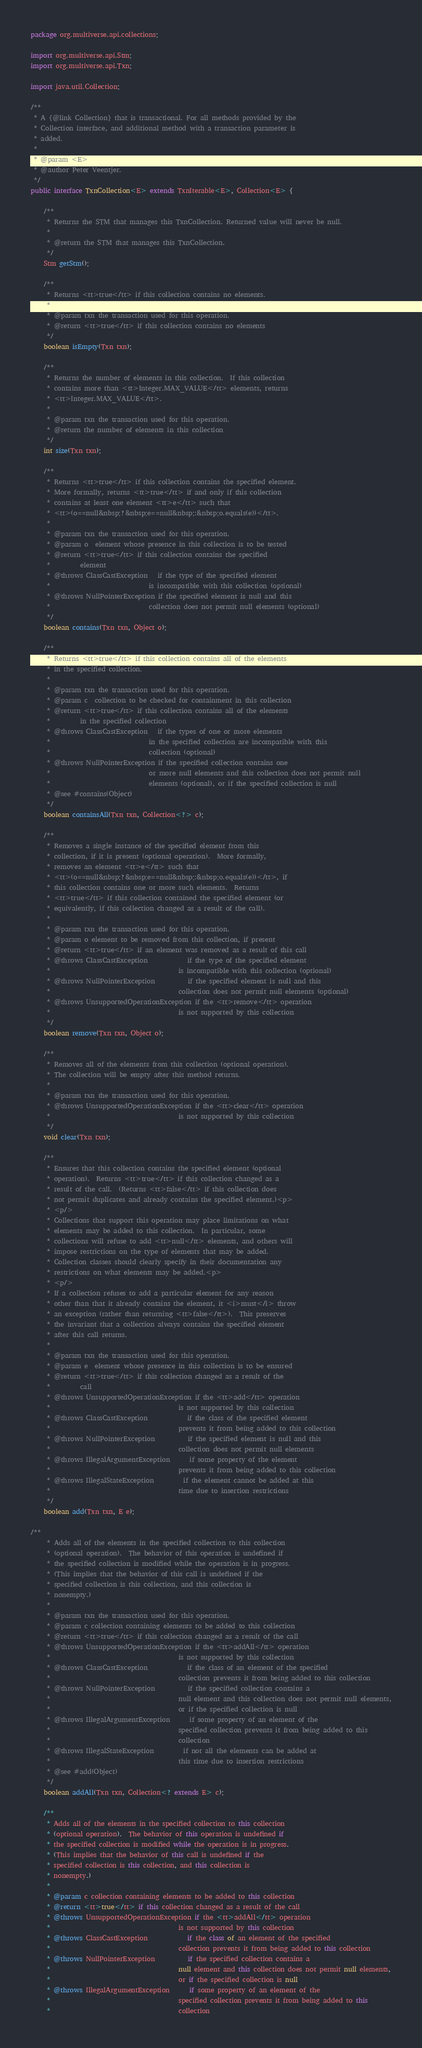<code> <loc_0><loc_0><loc_500><loc_500><_Java_>package org.multiverse.api.collections;

import org.multiverse.api.Stm;
import org.multiverse.api.Txn;

import java.util.Collection;

/**
 * A {@link Collection} that is transactional. For all methods provided by the
 * Collection interface, and additional method with a transaction parameter is
 * added.
 *
 * @param <E>
 * @author Peter Veentjer.
 */
public interface TxnCollection<E> extends TxnIterable<E>, Collection<E> {

    /**
     * Returns the STM that manages this TxnCollection. Returned value will never be null.
     *
     * @return the STM that manages this TxnCollection.
     */
    Stm getStm();

    /**
     * Returns <tt>true</tt> if this collection contains no elements.
     *
     * @param txn the transaction used for this operation.
     * @return <tt>true</tt> if this collection contains no elements
     */
    boolean isEmpty(Txn txn);

    /**
     * Returns the number of elements in this collection.  If this collection
     * contains more than <tt>Integer.MAX_VALUE</tt> elements, returns
     * <tt>Integer.MAX_VALUE</tt>.
     *
     * @param txn the transaction used for this operation.
     * @return the number of elements in this collection
     */
    int size(Txn txn);

    /**
     * Returns <tt>true</tt> if this collection contains the specified element.
     * More formally, returns <tt>true</tt> if and only if this collection
     * contains at least one element <tt>e</tt> such that
     * <tt>(o==null&nbsp;?&nbsp;e==null&nbsp;:&nbsp;o.equals(e))</tt>.
     *
     * @param txn the transaction used for this operation.
     * @param o  element whose presence in this collection is to be tested
     * @return <tt>true</tt> if this collection contains the specified
     *         element
     * @throws ClassCastException   if the type of the specified element
     *                              is incompatible with this collection (optional)
     * @throws NullPointerException if the specified element is null and this
     *                              collection does not permit null elements (optional)
     */
    boolean contains(Txn txn, Object o);

    /**
     * Returns <tt>true</tt> if this collection contains all of the elements
     * in the specified collection.
     *
     * @param txn the transaction used for this operation.
     * @param c  collection to be checked for containment in this collection
     * @return <tt>true</tt> if this collection contains all of the elements
     *         in the specified collection
     * @throws ClassCastException   if the types of one or more elements
     *                              in the specified collection are incompatible with this
     *                              collection (optional)
     * @throws NullPointerException if the specified collection contains one
     *                              or more null elements and this collection does not permit null
     *                              elements (optional), or if the specified collection is null
     * @see #contains(Object)
     */
    boolean containsAll(Txn txn, Collection<?> c);

    /**
     * Removes a single instance of the specified element from this
     * collection, if it is present (optional operation).  More formally,
     * removes an element <tt>e</tt> such that
     * <tt>(o==null&nbsp;?&nbsp;e==null&nbsp;:&nbsp;o.equals(e))</tt>, if
     * this collection contains one or more such elements.  Returns
     * <tt>true</tt> if this collection contained the specified element (or
     * equivalently, if this collection changed as a result of the call).
     *
     * @param txn the transaction used for this operation.
     * @param o element to be removed from this collection, if present
     * @return <tt>true</tt> if an element was removed as a result of this call
     * @throws ClassCastException            if the type of the specified element
     *                                       is incompatible with this collection (optional)
     * @throws NullPointerException          if the specified element is null and this
     *                                       collection does not permit null elements (optional)
     * @throws UnsupportedOperationException if the <tt>remove</tt> operation
     *                                       is not supported by this collection
     */
    boolean remove(Txn txn, Object o);

    /**
     * Removes all of the elements from this collection (optional operation).
     * The collection will be empty after this method returns.
     *
     * @param txn the transaction used for this operation.
     * @throws UnsupportedOperationException if the <tt>clear</tt> operation
     *                                       is not supported by this collection
     */
    void clear(Txn txn);

    /**
     * Ensures that this collection contains the specified element (optional
     * operation).  Returns <tt>true</tt> if this collection changed as a
     * result of the call.  (Returns <tt>false</tt> if this collection does
     * not permit duplicates and already contains the specified element.)<p>
     * <p/>
     * Collections that support this operation may place limitations on what
     * elements may be added to this collection.  In particular, some
     * collections will refuse to add <tt>null</tt> elements, and others will
     * impose restrictions on the type of elements that may be added.
     * Collection classes should clearly specify in their documentation any
     * restrictions on what elements may be added.<p>
     * <p/>
     * If a collection refuses to add a particular element for any reason
     * other than that it already contains the element, it <i>must</i> throw
     * an exception (rather than returning <tt>false</tt>).  This preserves
     * the invariant that a collection always contains the specified element
     * after this call returns.
     *
     * @param txn the transaction used for this operation.
     * @param e  element whose presence in this collection is to be ensured
     * @return <tt>true</tt> if this collection changed as a result of the
     *         call
     * @throws UnsupportedOperationException if the <tt>add</tt> operation
     *                                       is not supported by this collection
     * @throws ClassCastException            if the class of the specified element
     *                                       prevents it from being added to this collection
     * @throws NullPointerException          if the specified element is null and this
     *                                       collection does not permit null elements
     * @throws IllegalArgumentException      if some property of the element
     *                                       prevents it from being added to this collection
     * @throws IllegalStateException         if the element cannot be added at this
     *                                       time due to insertion restrictions
     */
    boolean add(Txn txn, E e);

/**
     * Adds all of the elements in the specified collection to this collection
     * (optional operation).  The behavior of this operation is undefined if
     * the specified collection is modified while the operation is in progress.
     * (This implies that the behavior of this call is undefined if the
     * specified collection is this collection, and this collection is
     * nonempty.)
     *
     * @param txn the transaction used for this operation.
     * @param c collection containing elements to be added to this collection
     * @return <tt>true</tt> if this collection changed as a result of the call
     * @throws UnsupportedOperationException if the <tt>addAll</tt> operation
     *                                       is not supported by this collection
     * @throws ClassCastException            if the class of an element of the specified
     *                                       collection prevents it from being added to this collection
     * @throws NullPointerException          if the specified collection contains a
     *                                       null element and this collection does not permit null elements,
     *                                       or if the specified collection is null
     * @throws IllegalArgumentException      if some property of an element of the
     *                                       specified collection prevents it from being added to this
     *                                       collection
     * @throws IllegalStateException         if not all the elements can be added at
     *                                       this time due to insertion restrictions
     * @see #add(Object)
     */
    boolean addAll(Txn txn, Collection<? extends E> c);

    /**
     * Adds all of the elements in the specified collection to this collection
     * (optional operation).  The behavior of this operation is undefined if
     * the specified collection is modified while the operation is in progress.
     * (This implies that the behavior of this call is undefined if the
     * specified collection is this collection, and this collection is
     * nonempty.)
     *
     * @param c collection containing elements to be added to this collection
     * @return <tt>true</tt> if this collection changed as a result of the call
     * @throws UnsupportedOperationException if the <tt>addAll</tt> operation
     *                                       is not supported by this collection
     * @throws ClassCastException            if the class of an element of the specified
     *                                       collection prevents it from being added to this collection
     * @throws NullPointerException          if the specified collection contains a
     *                                       null element and this collection does not permit null elements,
     *                                       or if the specified collection is null
     * @throws IllegalArgumentException      if some property of an element of the
     *                                       specified collection prevents it from being added to this
     *                                       collection</code> 